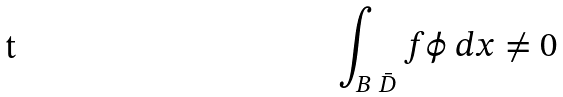Convert formula to latex. <formula><loc_0><loc_0><loc_500><loc_500>\int _ { B \ \bar { D } } f \phi \ d x \neq 0</formula> 